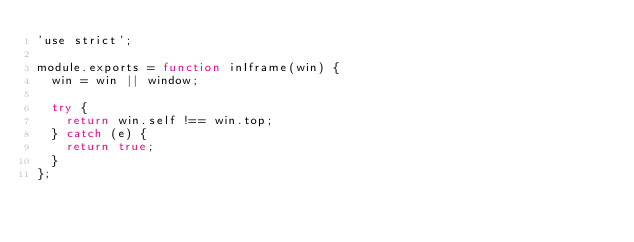Convert code to text. <code><loc_0><loc_0><loc_500><loc_500><_JavaScript_>'use strict';

module.exports = function inIframe(win) {
  win = win || window;

  try {
    return win.self !== win.top;
  } catch (e) {
    return true;
  }
};
</code> 